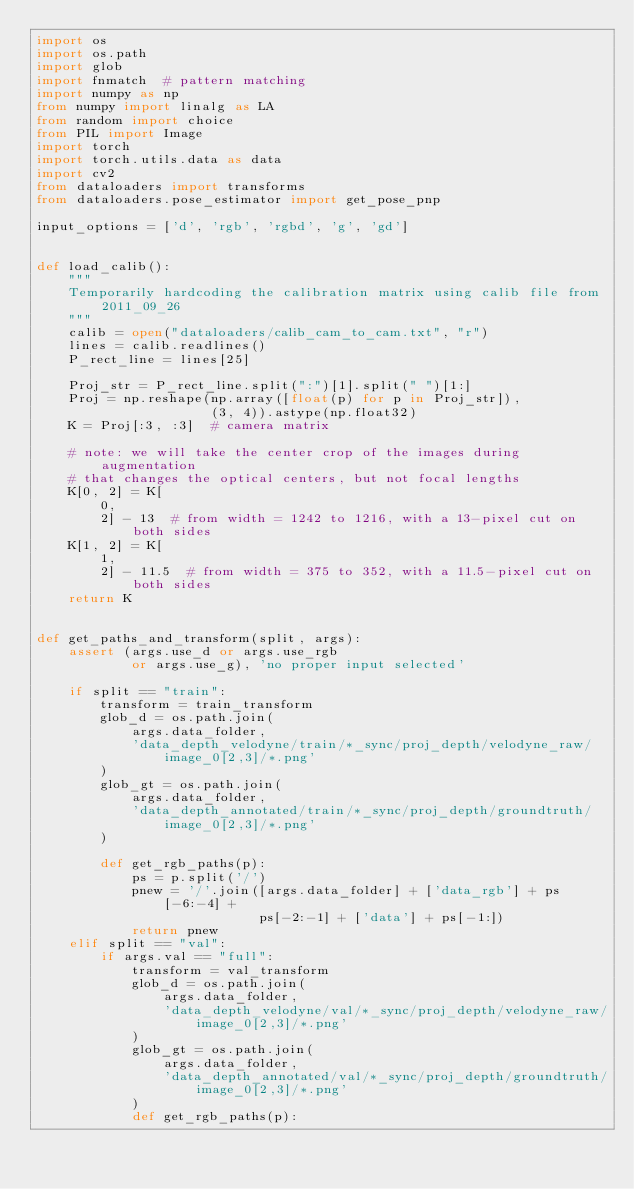<code> <loc_0><loc_0><loc_500><loc_500><_Python_>import os
import os.path
import glob
import fnmatch  # pattern matching
import numpy as np
from numpy import linalg as LA
from random import choice
from PIL import Image
import torch
import torch.utils.data as data
import cv2
from dataloaders import transforms
from dataloaders.pose_estimator import get_pose_pnp

input_options = ['d', 'rgb', 'rgbd', 'g', 'gd']


def load_calib():
    """
    Temporarily hardcoding the calibration matrix using calib file from 2011_09_26
    """
    calib = open("dataloaders/calib_cam_to_cam.txt", "r")
    lines = calib.readlines()
    P_rect_line = lines[25]

    Proj_str = P_rect_line.split(":")[1].split(" ")[1:]
    Proj = np.reshape(np.array([float(p) for p in Proj_str]),
                      (3, 4)).astype(np.float32)
    K = Proj[:3, :3]  # camera matrix

    # note: we will take the center crop of the images during augmentation
    # that changes the optical centers, but not focal lengths
    K[0, 2] = K[
        0,
        2] - 13  # from width = 1242 to 1216, with a 13-pixel cut on both sides
    K[1, 2] = K[
        1,
        2] - 11.5  # from width = 375 to 352, with a 11.5-pixel cut on both sides
    return K


def get_paths_and_transform(split, args):
    assert (args.use_d or args.use_rgb
            or args.use_g), 'no proper input selected'

    if split == "train":
        transform = train_transform
        glob_d = os.path.join(
            args.data_folder,
            'data_depth_velodyne/train/*_sync/proj_depth/velodyne_raw/image_0[2,3]/*.png'
        )
        glob_gt = os.path.join(
            args.data_folder,
            'data_depth_annotated/train/*_sync/proj_depth/groundtruth/image_0[2,3]/*.png'
        )

        def get_rgb_paths(p):
            ps = p.split('/')
            pnew = '/'.join([args.data_folder] + ['data_rgb'] + ps[-6:-4] +
                            ps[-2:-1] + ['data'] + ps[-1:])
            return pnew
    elif split == "val":
        if args.val == "full":
            transform = val_transform
            glob_d = os.path.join(
                args.data_folder,
                'data_depth_velodyne/val/*_sync/proj_depth/velodyne_raw/image_0[2,3]/*.png'
            )
            glob_gt = os.path.join(
                args.data_folder,
                'data_depth_annotated/val/*_sync/proj_depth/groundtruth/image_0[2,3]/*.png'
            )
            def get_rgb_paths(p):</code> 